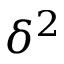Convert formula to latex. <formula><loc_0><loc_0><loc_500><loc_500>\delta ^ { 2 }</formula> 